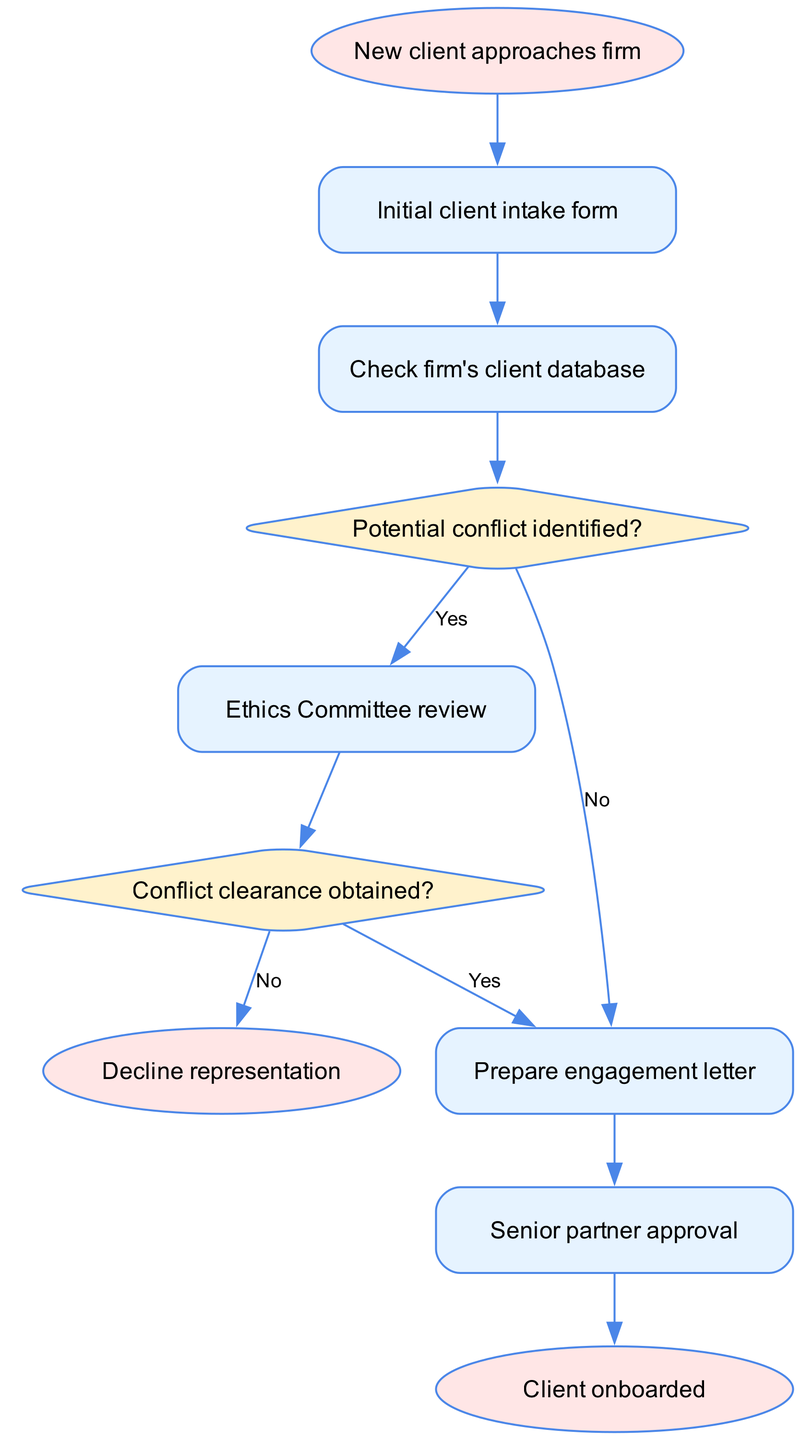What is the first step when a new client approaches the firm? The flowchart starts with the node labeled "New client approaches firm," indicating that this is the initial step in the onboarding process.
Answer: Initial client intake form How many nodes are present in the diagram? By counting each distinct element in the diagram, we see there are 10 nodes representing different steps in the client onboarding and conflict checking process.
Answer: 10 What is the output if a potential conflict is identified? If a potential conflict is identified, the flow moves to the "Ethics Committee review" node, based on the decision indicated by the edge connected to "Potential conflict identified?" labeled "Yes."
Answer: Ethics Committee review What happens after conflict clearance is obtained? Once conflict clearance is obtained (indicated by the "Yes" edge from "Conflict clearance obtained?"), the flowchart moves to the "Prepare engagement letter" node, which is a direct next step in the process.
Answer: Prepare engagement letter What is the shape of the node representing "Check firm's client database"? In the diagram, "Check firm's client database" is represented as a rectangular node, detailing the step in the onboarding procedure.
Answer: Rectangle What is the last step in the procedure before onboarding the client? The final step before the client is officially onboarded is "Senior partner approval," which must be completed successfully per the sequence in the flowchart.
Answer: Senior partner approval What occurs if conflict clearance is not obtained? If conflict clearance is not obtained (the edge labeled "No"), the process directs to "Decline representation," indicating that the firm cannot take on the client.
Answer: Decline representation Which nodes are decision points in the flowchart? The decision points, also known as diamond-shaped nodes, in this flowchart are "Potential conflict identified?" and "Conflict clearance obtained?" These indicate critical decision-making steps in the process.
Answer: Potential conflict identified? and Conflict clearance obtained? What is the final output of the flowchart? The flowchart culminates at the "Client onboarded" node, which indicates the successful completion of the onboarding process after all necessary steps have been followed, particularly following the approval by the senior partner.
Answer: Client onboarded 